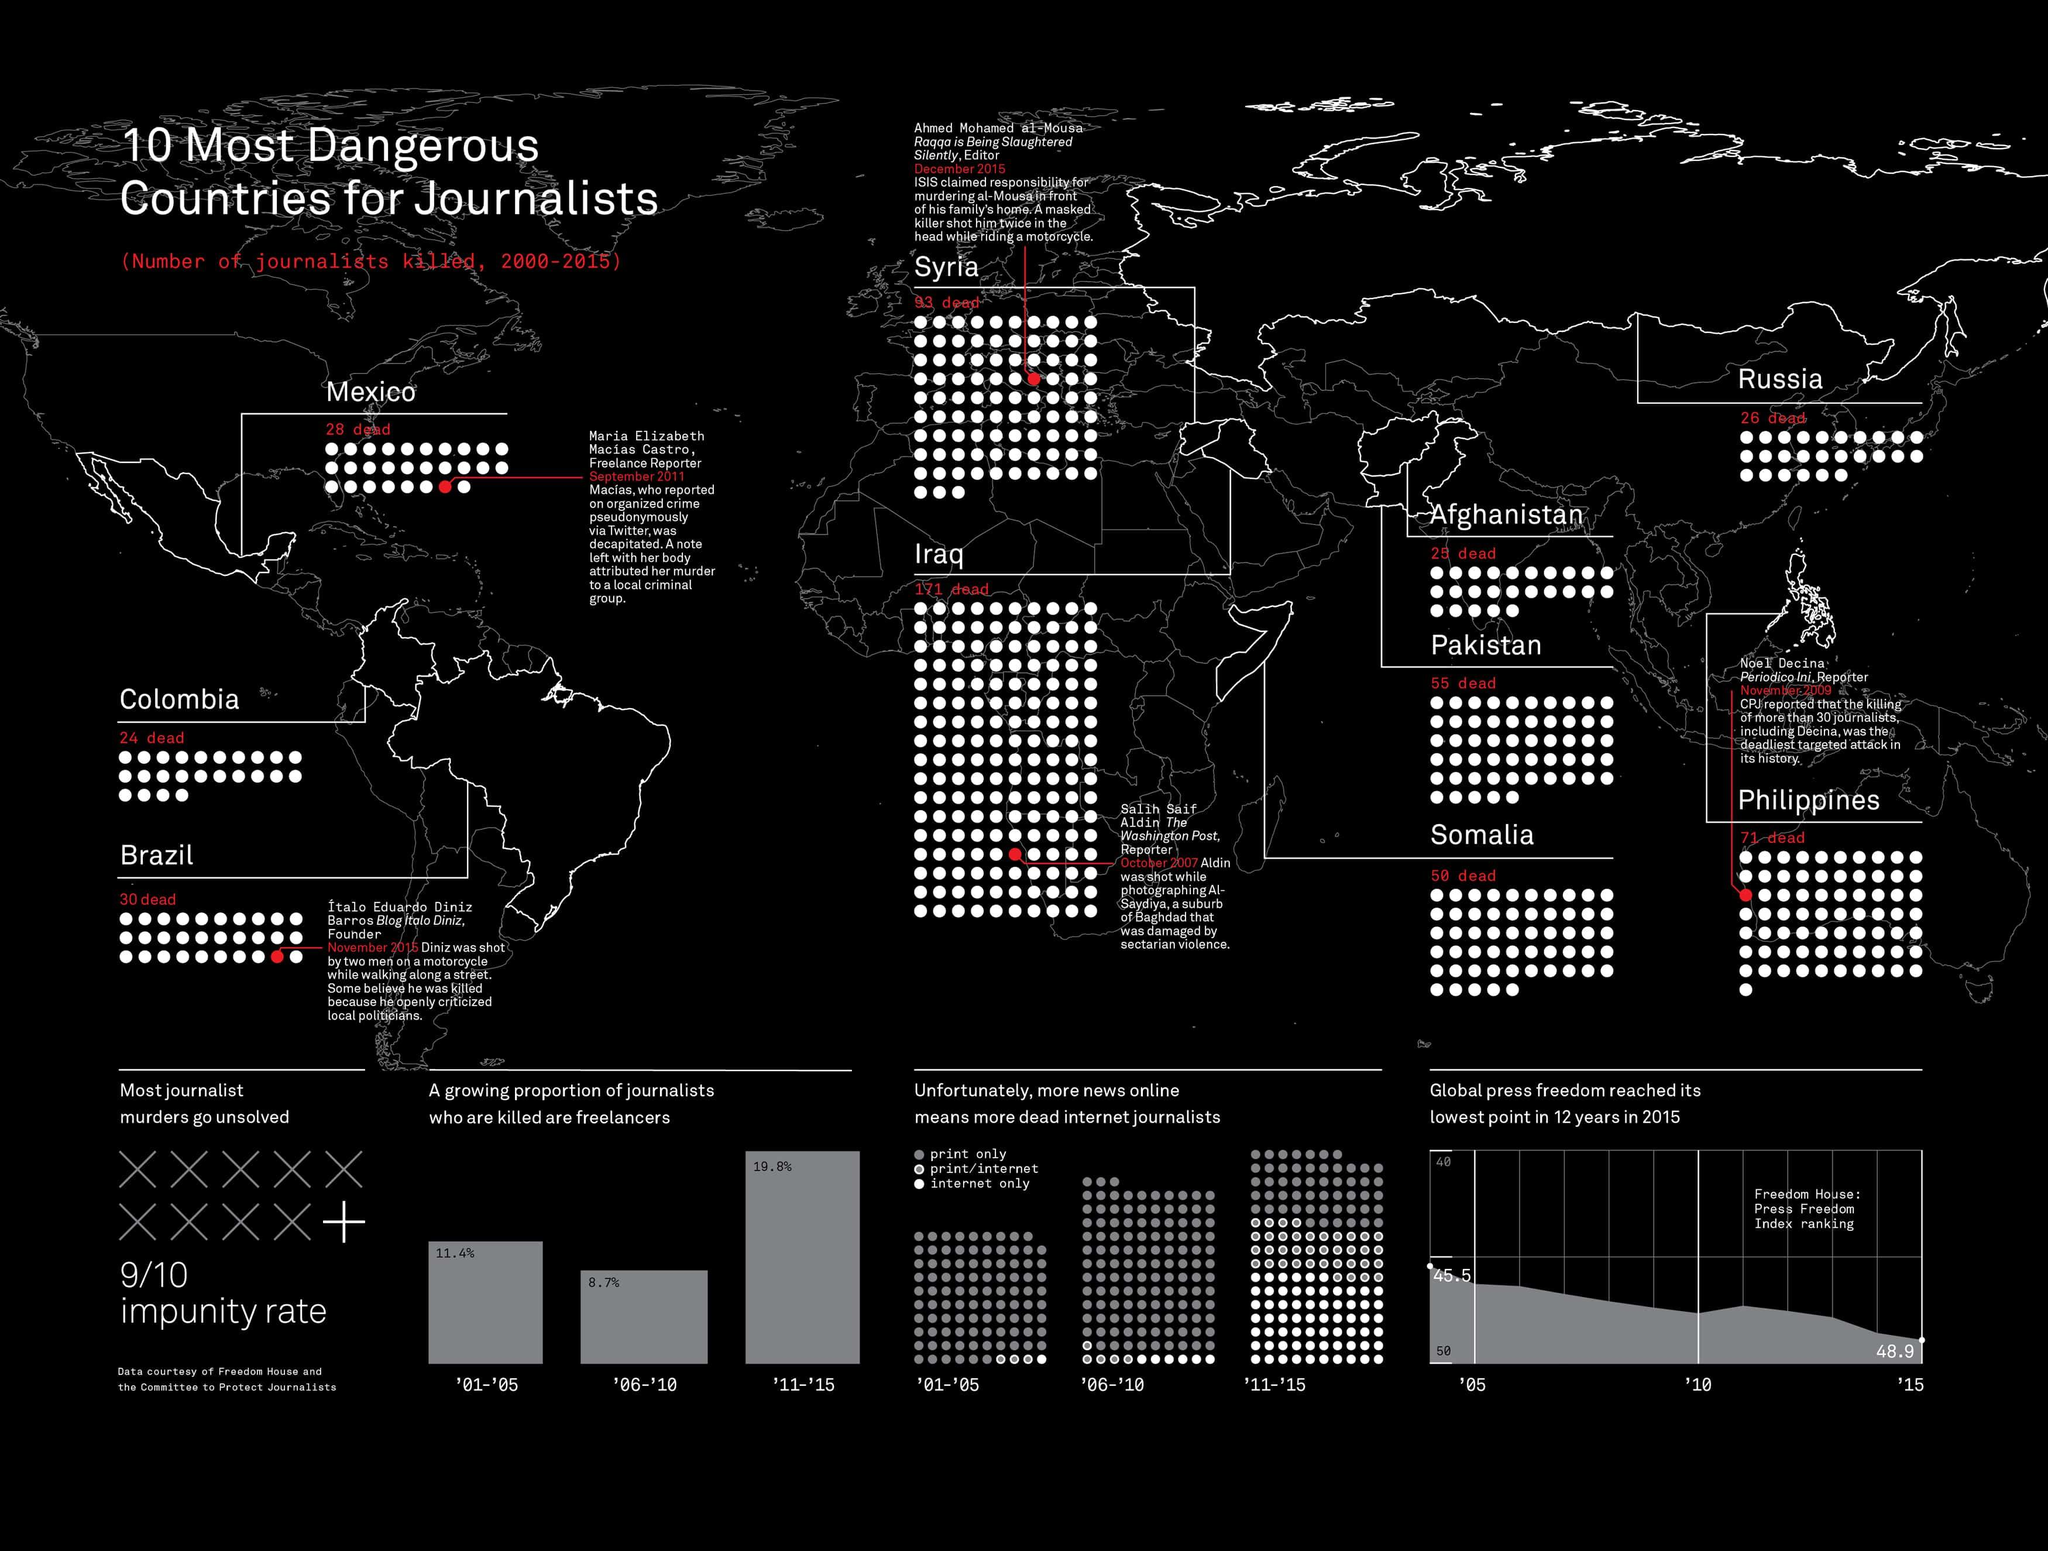List a handful of essential elements in this visual. During the years 2000 to 2015, a total of 55 journalists were killed in Pakistan. During the period of 2000-2015, at least 25 journalists were killed in Afghanistan. Iraq reported the highest number of journalists' deaths among the ten most dangerous countries for journalists during the years 2000-2015. During the period of 2000-2015, Syria reported the second-highest number of journalist deaths among the ten most dangerous countries for journalists, followed by Somalia, Iraq, Pakistan, Russia, Philippines, Brazil, Colombia, China, and Mexico. 